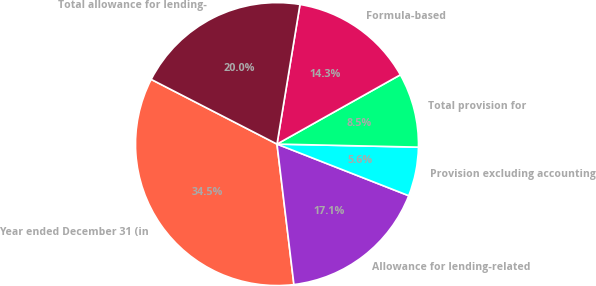Convert chart to OTSL. <chart><loc_0><loc_0><loc_500><loc_500><pie_chart><fcel>Year ended December 31 (in<fcel>Allowance for lending-related<fcel>Provision excluding accounting<fcel>Total provision for<fcel>Formula-based<fcel>Total allowance for lending-<nl><fcel>34.47%<fcel>17.15%<fcel>5.6%<fcel>8.49%<fcel>14.26%<fcel>20.04%<nl></chart> 